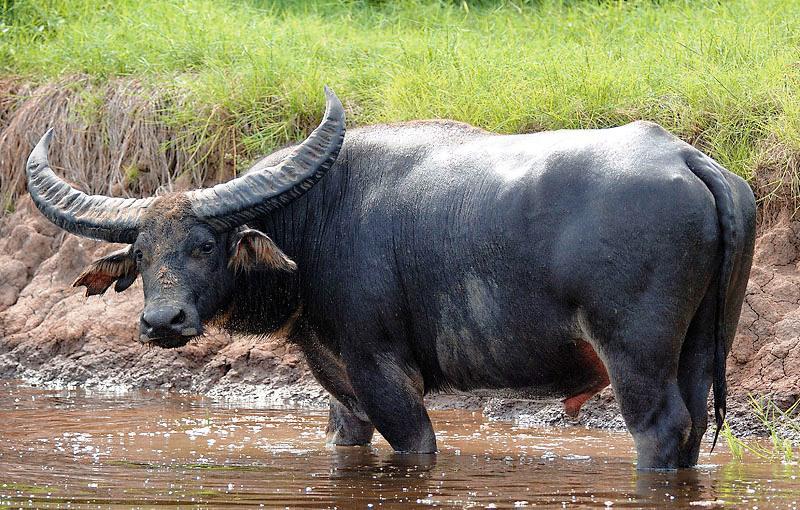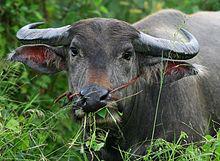The first image is the image on the left, the second image is the image on the right. Given the left and right images, does the statement "An image contains a water buffalo standing on water." hold true? Answer yes or no. Yes. The first image is the image on the left, the second image is the image on the right. Given the left and right images, does the statement "An image shows one water buffalo standing in water that does not reach its chest." hold true? Answer yes or no. Yes. 